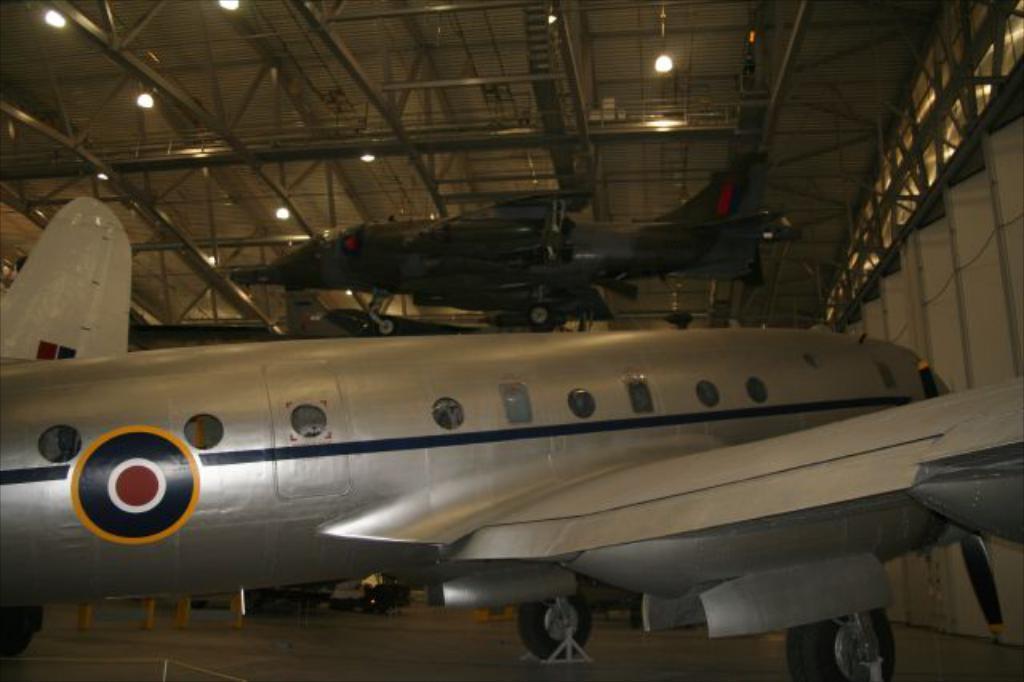Could you give a brief overview of what you see in this image? In this image, there are a few airways. We can see the ground with some objects. We can also see the wall. We can see the shed with some lights at the top. 